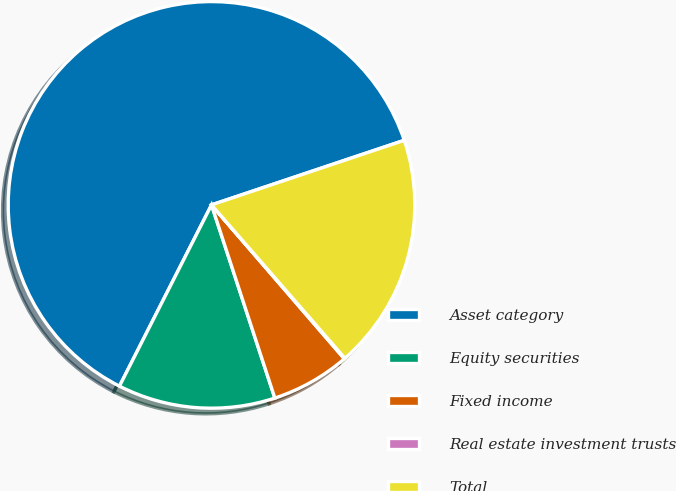<chart> <loc_0><loc_0><loc_500><loc_500><pie_chart><fcel>Asset category<fcel>Equity securities<fcel>Fixed income<fcel>Real estate investment trusts<fcel>Total<nl><fcel>62.37%<fcel>12.52%<fcel>6.29%<fcel>0.06%<fcel>18.75%<nl></chart> 